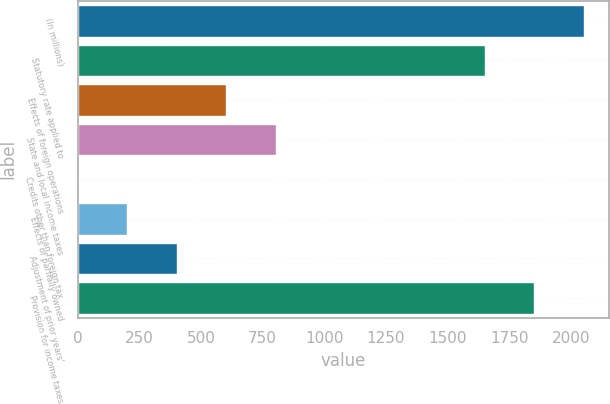Convert chart to OTSL. <chart><loc_0><loc_0><loc_500><loc_500><bar_chart><fcel>(In millions)<fcel>Statutory rate applied to<fcel>Effects of foreign operations<fcel>State and local income taxes<fcel>Credits other than foreign tax<fcel>Effects of partially owned<fcel>Adjustment of prior years'<fcel>Provision for income taxes<nl><fcel>2052.6<fcel>1652<fcel>602.9<fcel>803.2<fcel>2<fcel>202.3<fcel>402.6<fcel>1852.3<nl></chart> 